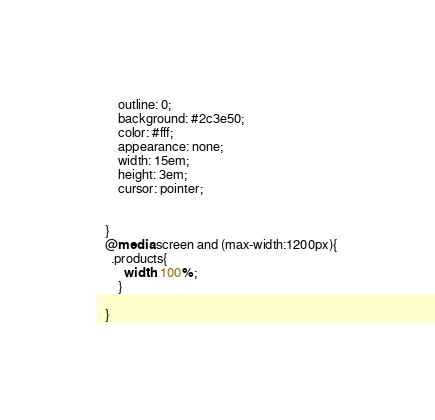Convert code to text. <code><loc_0><loc_0><loc_500><loc_500><_CSS_>      outline: 0;
      background: #2c3e50;
      color: #fff;
      appearance: none;
      width: 15em;
      height: 3em;
      cursor: pointer;
      
      
  }
  @media screen and (max-width:1200px){
    .products{
        width: 100%;
      }
    
  }</code> 